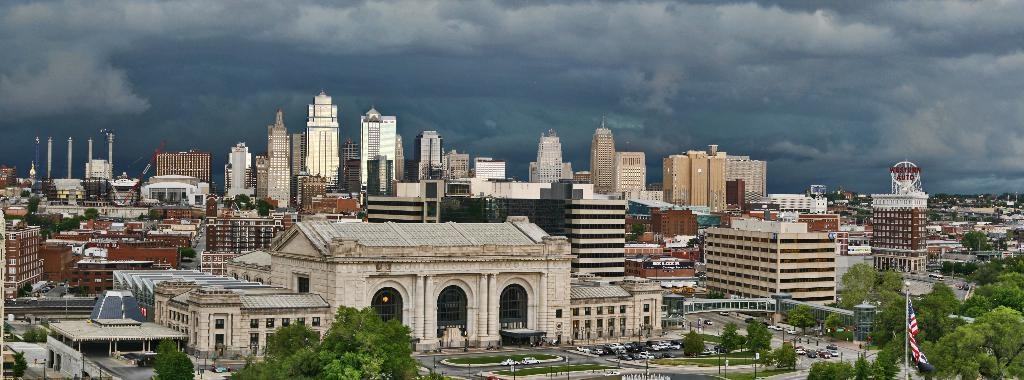What is located in the center of the image? Buildings, trees, plants, grass, poles, vehicles, banners, and pillars are located in the center of the image. What type of vegetation is present in the center of the image? Trees, plants, and grass are present in the center of the image. What structures are visible in the center of the image? Buildings, poles, pillars, and a flag are visible in the center of the image. What is visible in the background of the image? The sky and clouds are visible in the background of the image. What type of transportation can be seen in the center of the image? Vehicles are present in the center of the image. What type of drum can be heard playing in the image? There is no drum present or audible in the image. Can you see any birds flying in the image? There are no birds visible in the image. 